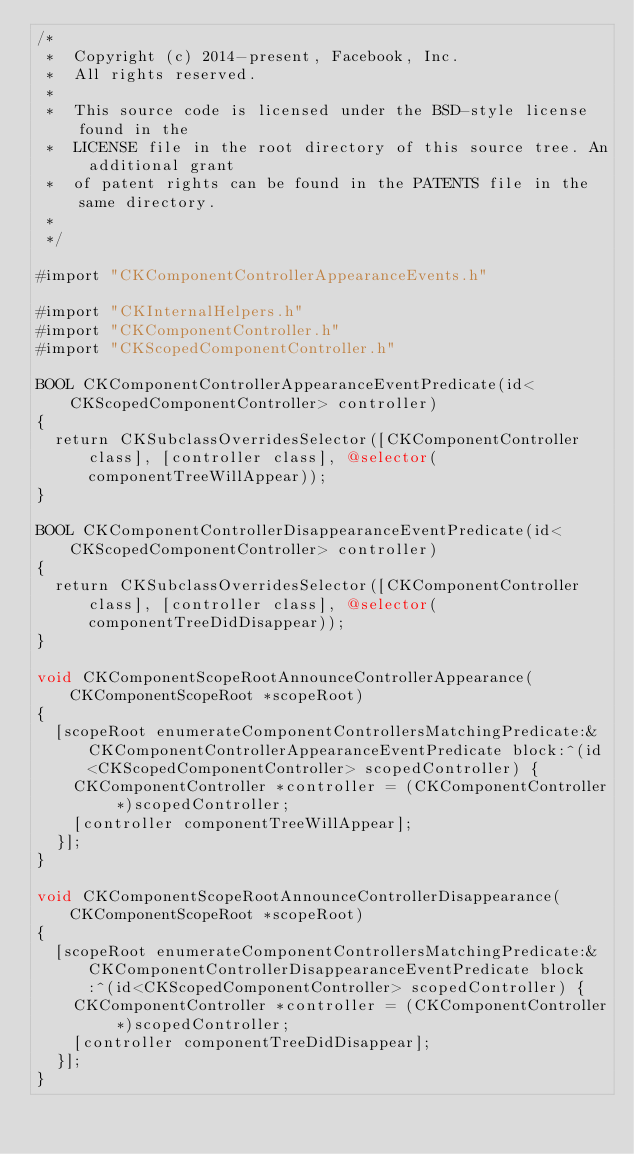Convert code to text. <code><loc_0><loc_0><loc_500><loc_500><_ObjectiveC_>/*
 *  Copyright (c) 2014-present, Facebook, Inc.
 *  All rights reserved.
 *
 *  This source code is licensed under the BSD-style license found in the
 *  LICENSE file in the root directory of this source tree. An additional grant
 *  of patent rights can be found in the PATENTS file in the same directory.
 *
 */

#import "CKComponentControllerAppearanceEvents.h"

#import "CKInternalHelpers.h"
#import "CKComponentController.h"
#import "CKScopedComponentController.h"

BOOL CKComponentControllerAppearanceEventPredicate(id<CKScopedComponentController> controller)
{
  return CKSubclassOverridesSelector([CKComponentController class], [controller class], @selector(componentTreeWillAppear));
}

BOOL CKComponentControllerDisappearanceEventPredicate(id<CKScopedComponentController> controller)
{
  return CKSubclassOverridesSelector([CKComponentController class], [controller class], @selector(componentTreeDidDisappear));
}

void CKComponentScopeRootAnnounceControllerAppearance(CKComponentScopeRoot *scopeRoot)
{
  [scopeRoot enumerateComponentControllersMatchingPredicate:&CKComponentControllerAppearanceEventPredicate block:^(id<CKScopedComponentController> scopedController) {
    CKComponentController *controller = (CKComponentController *)scopedController;
    [controller componentTreeWillAppear];
  }];
}

void CKComponentScopeRootAnnounceControllerDisappearance(CKComponentScopeRoot *scopeRoot)
{
  [scopeRoot enumerateComponentControllersMatchingPredicate:&CKComponentControllerDisappearanceEventPredicate block:^(id<CKScopedComponentController> scopedController) {
    CKComponentController *controller = (CKComponentController *)scopedController;
    [controller componentTreeDidDisappear];
  }];
}
</code> 